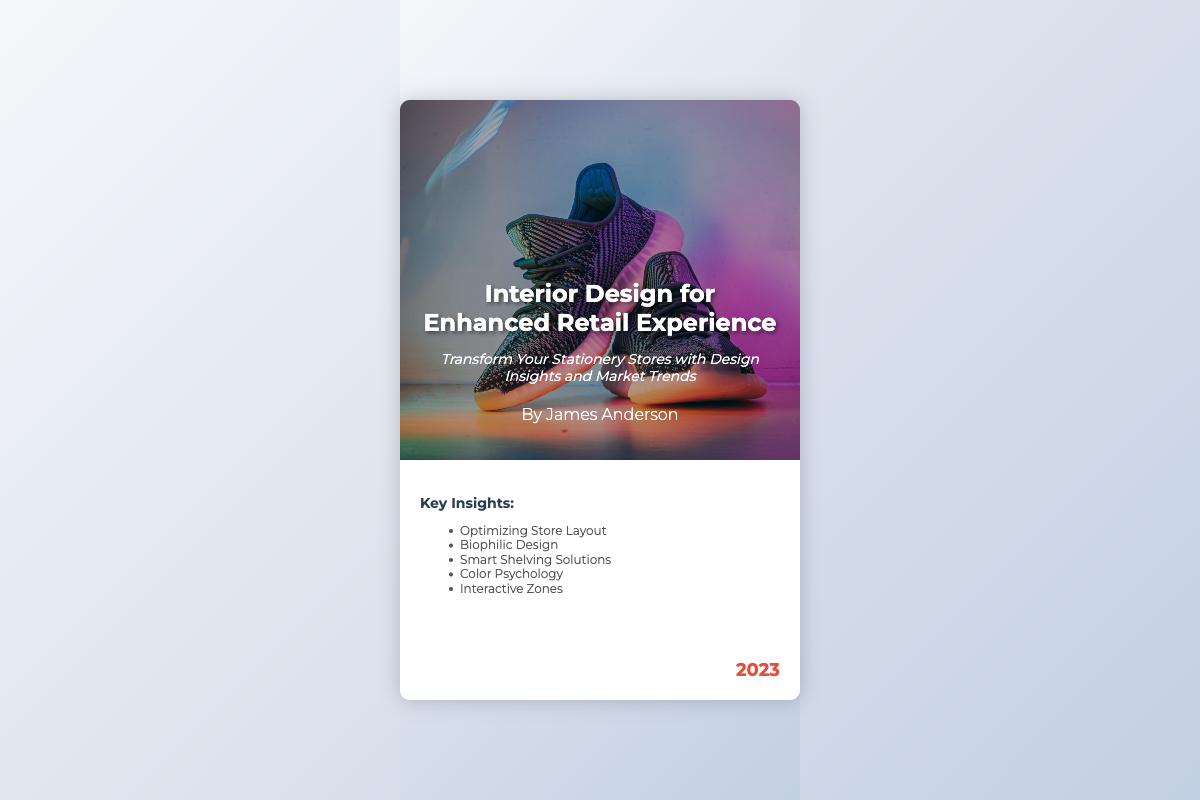What is the title of the book? The title is prominently displayed on the cover of the book.
Answer: Interior Design for Enhanced Retail Experience Who is the author of the book? The author's name is located under the title on the cover.
Answer: James Anderson What year was the book published? The year of publication is shown at the bottom right corner of the cover.
Answer: 2023 Which publishing company released this book? The publisher's name is included at the bottom of the info area on the cover.
Answer: Retail Design Press What is one of the key insights mentioned in the book? Key insights are listed in the key points section of the info area.
Answer: Optimizing Store Layout What design concept focuses on integrating nature into the retail experience? The relevant design concept is included in the key insights list.
Answer: Biophilic Design What is the main tagline of the book? The tagline sums up the book's focus and is located in the title area.
Answer: Transform Your Stationery Stores with Design Insights and Market Trends How many key insights are listed on the cover? The number of key insights is evident in the bulleted list in the key points section.
Answer: Five 